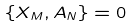Convert formula to latex. <formula><loc_0><loc_0><loc_500><loc_500>\{ X _ { M } , A _ { N } \} = 0</formula> 